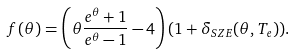<formula> <loc_0><loc_0><loc_500><loc_500>f ( \theta ) = \left ( \theta \frac { e ^ { \theta } + 1 } { e ^ { \theta } - 1 } - 4 \right ) ( 1 + \delta _ { S Z E } ( \theta , T _ { e } ) ) .</formula> 